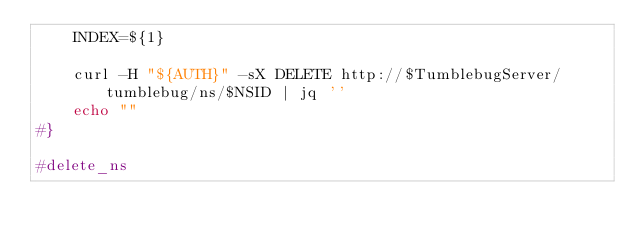<code> <loc_0><loc_0><loc_500><loc_500><_Bash_>    INDEX=${1}

    curl -H "${AUTH}" -sX DELETE http://$TumblebugServer/tumblebug/ns/$NSID | jq ''
    echo ""
#}

#delete_ns</code> 